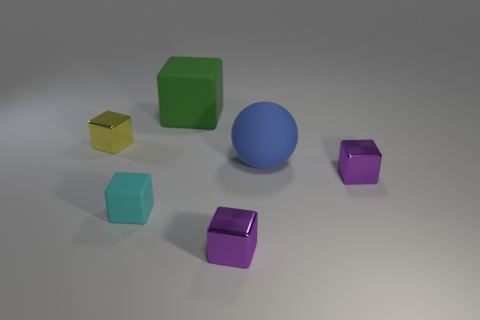Does the big blue thing have the same material as the big cube?
Ensure brevity in your answer.  Yes. Are there fewer green rubber objects to the left of the cyan rubber object than blue rubber objects that are in front of the green cube?
Provide a succinct answer. Yes. What number of large balls are in front of the big thing in front of the shiny block behind the large blue rubber object?
Your response must be concise. 0. There is a matte ball that is the same size as the green block; what color is it?
Your response must be concise. Blue. Is there another large thing that has the same shape as the cyan object?
Offer a terse response. Yes. There is a tiny shiny thing on the left side of the green thing that is to the left of the big ball; is there a green matte object in front of it?
Give a very brief answer. No. There is a thing that is the same size as the green cube; what is its shape?
Give a very brief answer. Sphere. What is the color of the big thing that is the same shape as the small cyan thing?
Offer a terse response. Green. What number of things are either big green rubber things or yellow blocks?
Your response must be concise. 2. Does the purple object that is in front of the small cyan rubber thing have the same shape as the metal object that is left of the large green rubber thing?
Ensure brevity in your answer.  Yes. 